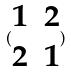<formula> <loc_0><loc_0><loc_500><loc_500>( \begin{matrix} 1 & 2 \\ 2 & 1 \end{matrix} )</formula> 